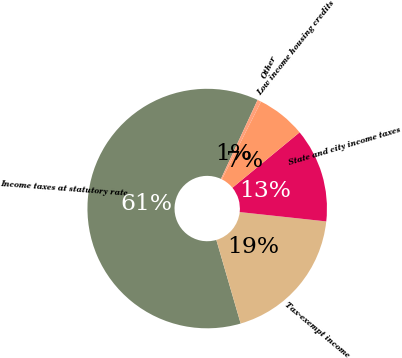Convert chart. <chart><loc_0><loc_0><loc_500><loc_500><pie_chart><fcel>Income taxes at statutory rate<fcel>Tax-exempt income<fcel>State and city income taxes<fcel>Low income housing credits<fcel>Other<nl><fcel>61.42%<fcel>18.78%<fcel>12.69%<fcel>6.6%<fcel>0.51%<nl></chart> 